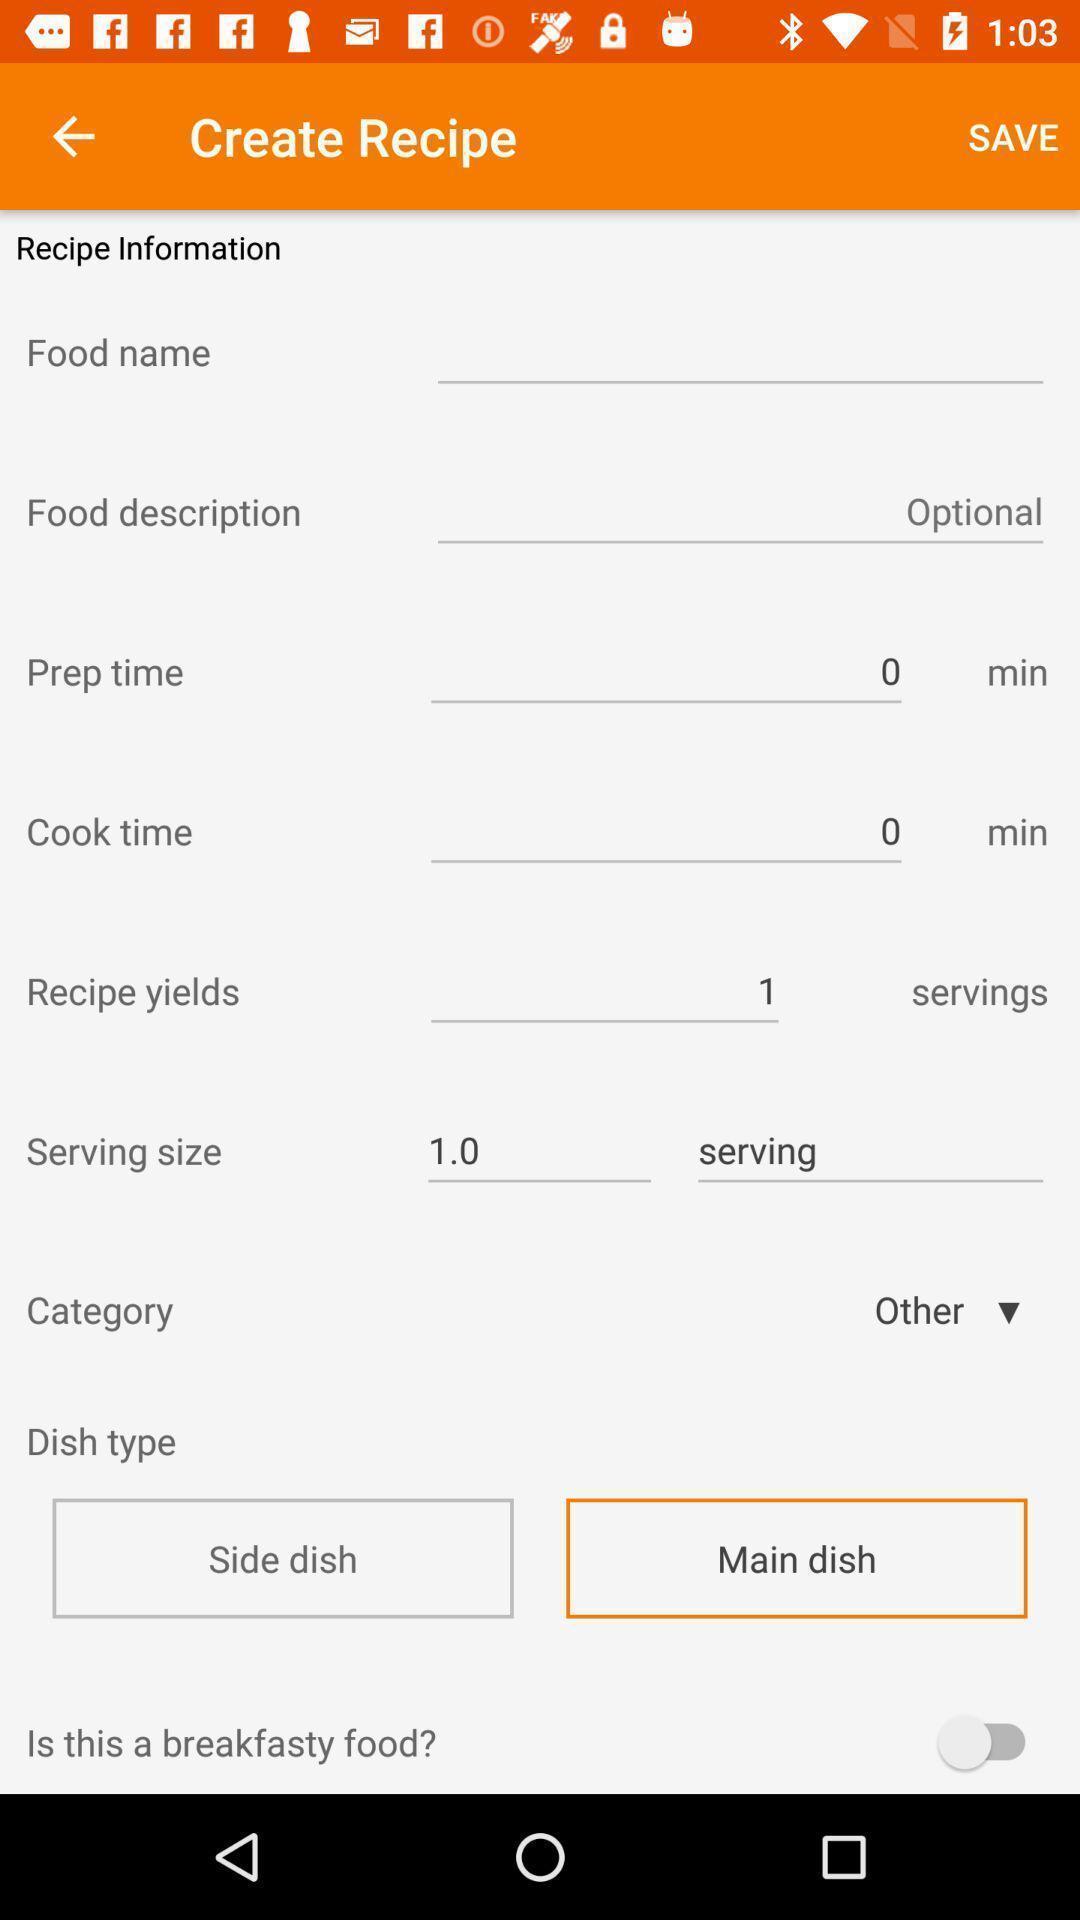Describe the content in this image. Screen shows create recipe options in a food application. 